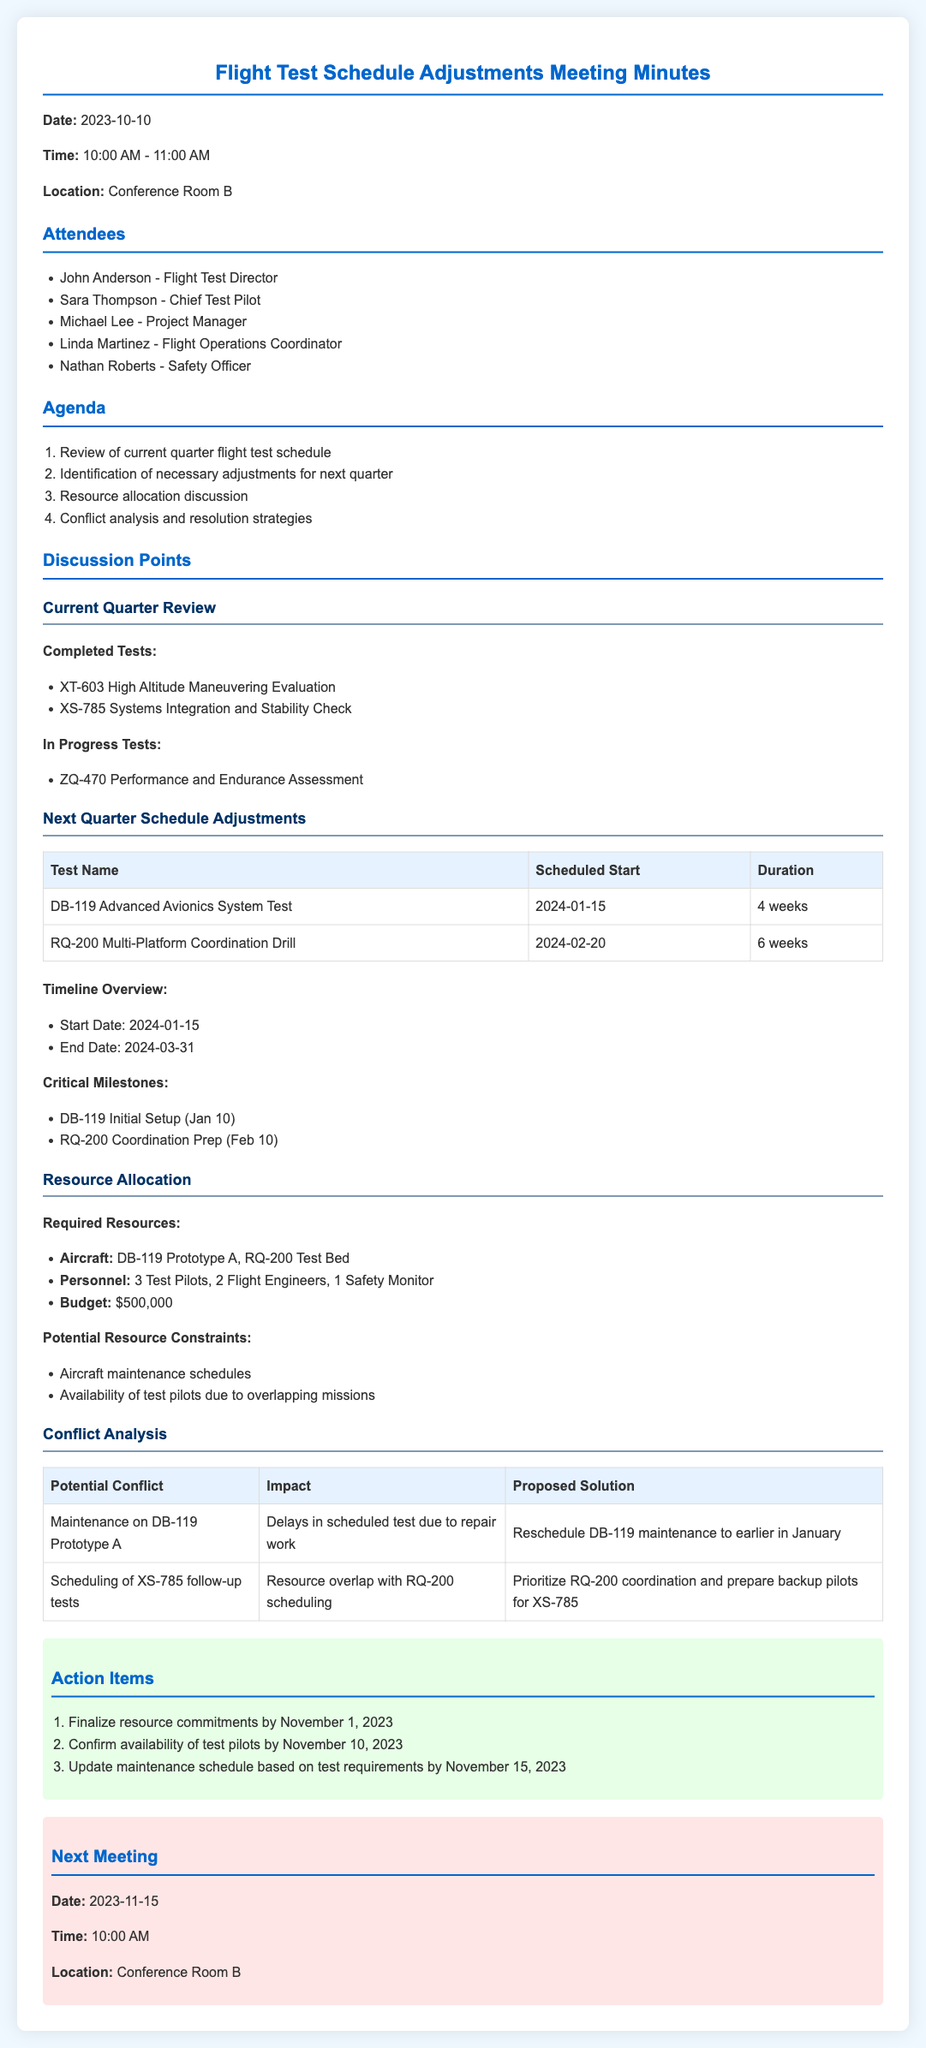what is the date of the meeting? The date of the meeting is clearly stated at the beginning of the document.
Answer: 2023-10-10 who is the Chief Test Pilot? The document lists the attendees and identifies the Chief Test Pilot.
Answer: Sara Thompson what are the scheduled start dates for the tests? The document provides a table with the scheduled start dates for each test in the next quarter.
Answer: 2024-01-15, 2024-02-20 how many test pilots are required? The resource allocation section specifies the number of personnel required for the tests.
Answer: 3 Test Pilots what is the impact of maintenance on DB-119 Prototype A? The conflict analysis section describes the impact of potential conflicts on the test schedule.
Answer: Delays in scheduled test due to repair work what milestone occurs on January 10? Critical milestones are outlined, indicating significant dates in the upcoming schedule.
Answer: DB-119 Initial Setup when is the next meeting scheduled? The next meeting details are provided toward the end of the document.
Answer: 2023-11-15 what is the total budget for the next quarter flight tests? The required resources section mentions the budget allocated for the upcoming tests.
Answer: $500,000 